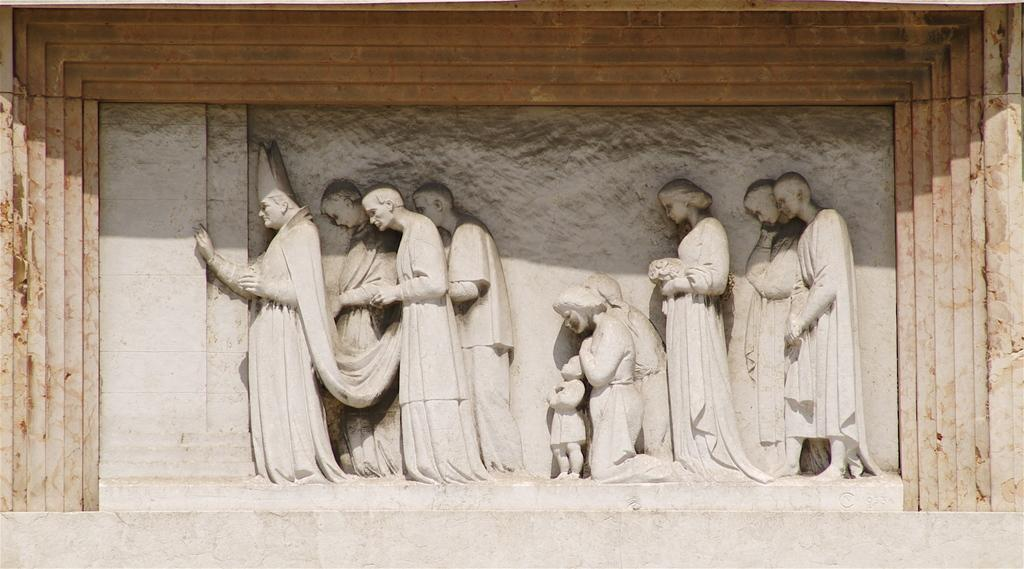What is the main subject in the center of the image? There are sculptures in the center of the image. Where are the sculptures located? The sculptures are on a wall. What is visible at the bottom of the image? There is a wall at the bottom of the image. What type of skirt is hanging from the tree in the image? There is no tree or skirt present in the image; it features sculptures on a wall. What material are the sculptures made of in the image? The provided facts do not mention the material of the sculptures, so we cannot determine their composition from the image. 